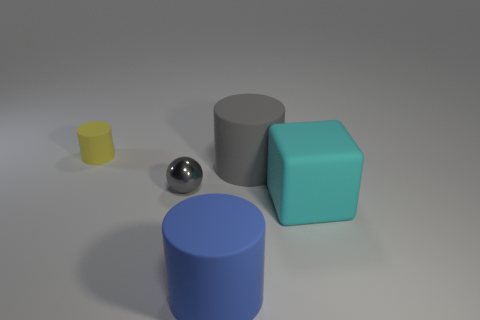Are there any yellow rubber objects of the same size as the metal sphere?
Give a very brief answer. Yes. Do the big cyan thing and the gray object to the left of the large blue rubber thing have the same material?
Offer a very short reply. No. Are there more gray balls than purple matte things?
Make the answer very short. Yes. What number of blocks are tiny gray rubber things or small things?
Offer a terse response. 0. The big cube is what color?
Your answer should be very brief. Cyan. There is a matte cylinder that is in front of the gray metallic object; is it the same size as the gray object that is to the right of the metal sphere?
Offer a terse response. Yes. Is the number of large blocks less than the number of things?
Your answer should be compact. Yes. What number of cyan objects are behind the yellow rubber cylinder?
Offer a very short reply. 0. What is the material of the large gray object?
Give a very brief answer. Rubber. Is the number of matte objects to the left of the tiny yellow cylinder less than the number of gray metal balls?
Offer a terse response. Yes. 